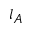Convert formula to latex. <formula><loc_0><loc_0><loc_500><loc_500>l _ { A }</formula> 